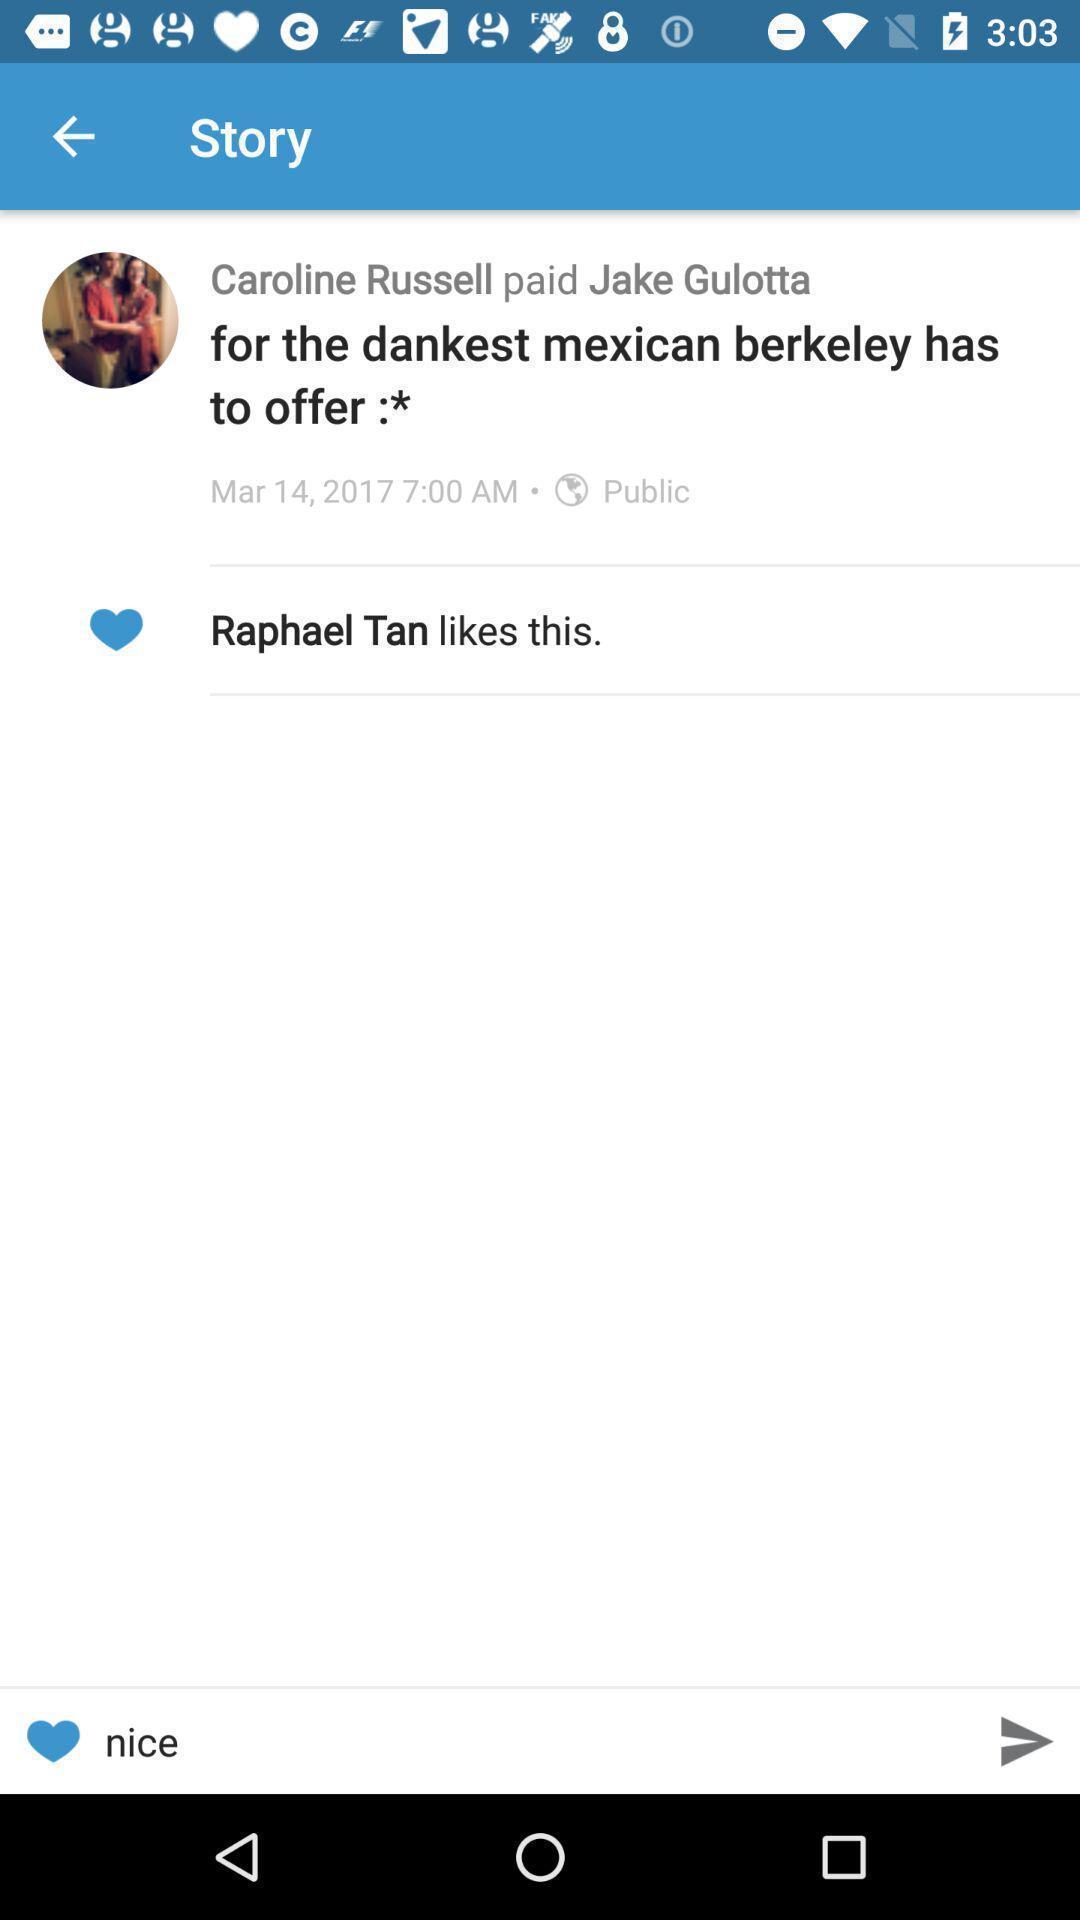Provide a detailed account of this screenshot. Screen showing the story. 